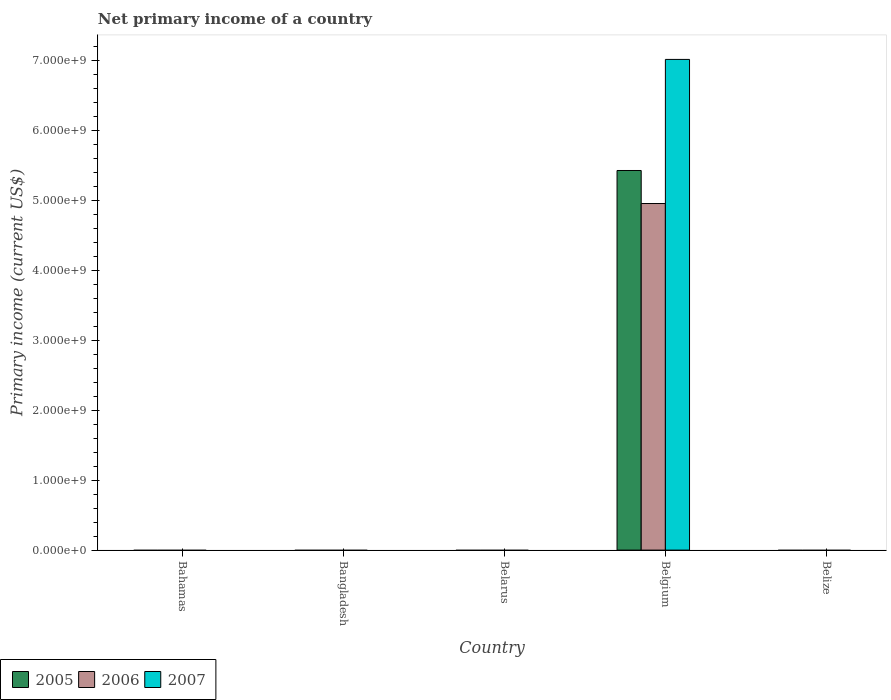How many different coloured bars are there?
Your answer should be compact. 3. Are the number of bars on each tick of the X-axis equal?
Provide a short and direct response. No. How many bars are there on the 2nd tick from the right?
Provide a succinct answer. 3. What is the primary income in 2005 in Belgium?
Keep it short and to the point. 5.42e+09. Across all countries, what is the maximum primary income in 2007?
Your response must be concise. 7.01e+09. In which country was the primary income in 2007 maximum?
Provide a short and direct response. Belgium. What is the total primary income in 2007 in the graph?
Your answer should be compact. 7.01e+09. What is the average primary income in 2007 per country?
Your answer should be very brief. 1.40e+09. What is the difference between the primary income of/in 2005 and primary income of/in 2006 in Belgium?
Your answer should be compact. 4.72e+08. What is the difference between the highest and the lowest primary income in 2007?
Offer a terse response. 7.01e+09. In how many countries, is the primary income in 2007 greater than the average primary income in 2007 taken over all countries?
Make the answer very short. 1. How many bars are there?
Your answer should be compact. 3. Are all the bars in the graph horizontal?
Your response must be concise. No. How many countries are there in the graph?
Provide a short and direct response. 5. Are the values on the major ticks of Y-axis written in scientific E-notation?
Make the answer very short. Yes. Where does the legend appear in the graph?
Provide a succinct answer. Bottom left. How many legend labels are there?
Your answer should be compact. 3. What is the title of the graph?
Your answer should be compact. Net primary income of a country. Does "2014" appear as one of the legend labels in the graph?
Offer a terse response. No. What is the label or title of the X-axis?
Provide a short and direct response. Country. What is the label or title of the Y-axis?
Your response must be concise. Primary income (current US$). What is the Primary income (current US$) of 2005 in Bahamas?
Your response must be concise. 0. What is the Primary income (current US$) of 2006 in Bahamas?
Make the answer very short. 0. What is the Primary income (current US$) of 2006 in Belarus?
Your answer should be compact. 0. What is the Primary income (current US$) of 2005 in Belgium?
Your answer should be compact. 5.42e+09. What is the Primary income (current US$) of 2006 in Belgium?
Provide a succinct answer. 4.95e+09. What is the Primary income (current US$) of 2007 in Belgium?
Your answer should be very brief. 7.01e+09. What is the Primary income (current US$) of 2005 in Belize?
Provide a succinct answer. 0. What is the Primary income (current US$) of 2007 in Belize?
Offer a very short reply. 0. Across all countries, what is the maximum Primary income (current US$) in 2005?
Offer a terse response. 5.42e+09. Across all countries, what is the maximum Primary income (current US$) in 2006?
Keep it short and to the point. 4.95e+09. Across all countries, what is the maximum Primary income (current US$) in 2007?
Your response must be concise. 7.01e+09. Across all countries, what is the minimum Primary income (current US$) in 2005?
Provide a succinct answer. 0. Across all countries, what is the minimum Primary income (current US$) in 2007?
Offer a terse response. 0. What is the total Primary income (current US$) of 2005 in the graph?
Offer a terse response. 5.42e+09. What is the total Primary income (current US$) of 2006 in the graph?
Give a very brief answer. 4.95e+09. What is the total Primary income (current US$) of 2007 in the graph?
Give a very brief answer. 7.01e+09. What is the average Primary income (current US$) of 2005 per country?
Offer a very short reply. 1.08e+09. What is the average Primary income (current US$) of 2006 per country?
Offer a terse response. 9.90e+08. What is the average Primary income (current US$) of 2007 per country?
Keep it short and to the point. 1.40e+09. What is the difference between the Primary income (current US$) of 2005 and Primary income (current US$) of 2006 in Belgium?
Make the answer very short. 4.72e+08. What is the difference between the Primary income (current US$) in 2005 and Primary income (current US$) in 2007 in Belgium?
Keep it short and to the point. -1.59e+09. What is the difference between the Primary income (current US$) of 2006 and Primary income (current US$) of 2007 in Belgium?
Your answer should be very brief. -2.06e+09. What is the difference between the highest and the lowest Primary income (current US$) of 2005?
Offer a very short reply. 5.42e+09. What is the difference between the highest and the lowest Primary income (current US$) in 2006?
Provide a succinct answer. 4.95e+09. What is the difference between the highest and the lowest Primary income (current US$) of 2007?
Make the answer very short. 7.01e+09. 